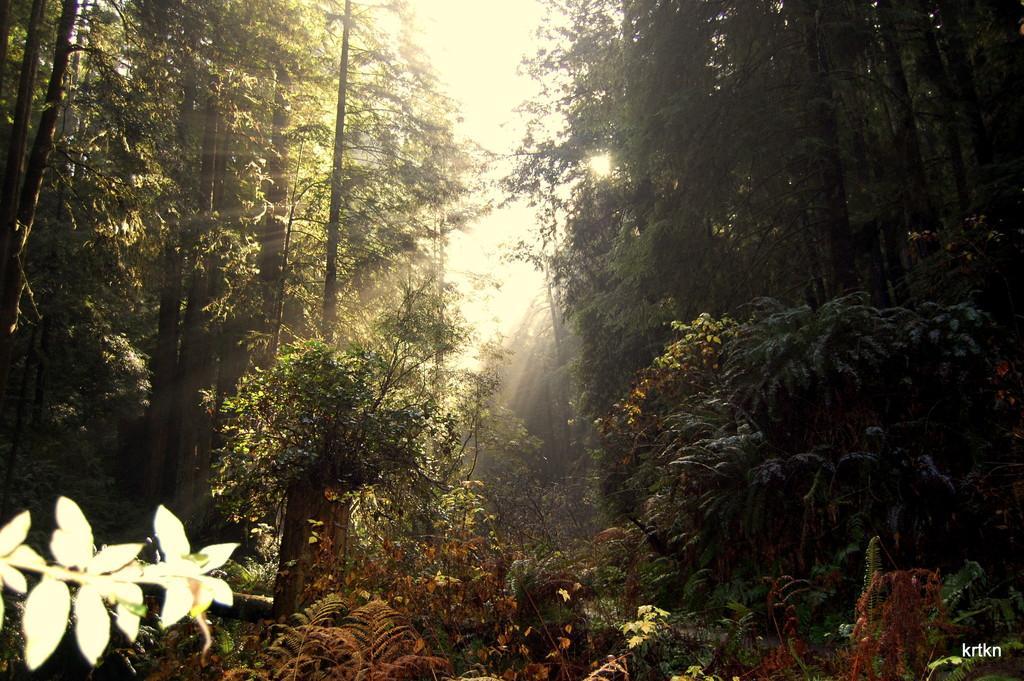In one or two sentences, can you explain what this image depicts? In this image we can see tall trees and the sunlight. 